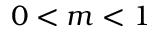Convert formula to latex. <formula><loc_0><loc_0><loc_500><loc_500>0 < m < 1</formula> 